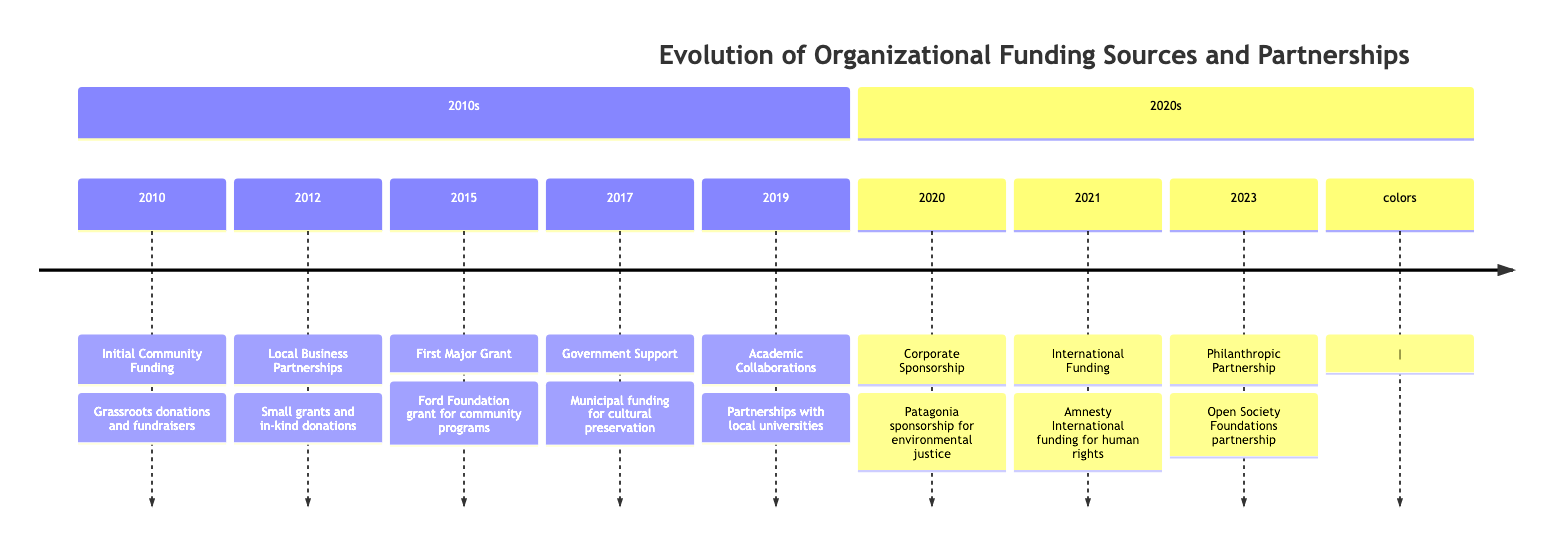What year did the organization receive its first significant grant? The timeline indicates that the organization secured its first major grant from the Ford Foundation in the year 2015.
Answer: 2015 What partnership was established in 2023? According to the diagram, in 2023 the organization established an ongoing partnership with the Open Society Foundations.
Answer: Open Society Foundations How many major grants or funding sources are listed prior to 2020? By counting the relevant events from the years 2010 to 2019, there are five major grants or funding sources listed before 2020: Initial Community Funding, Local Business Partnerships, First Major Grant, Government Support, and Academic Collaborations.
Answer: 5 Which organization provided funding for human rights advocacy in 2021? The timeline specifies that Amnesty International provided funding for human rights advocacy in the year 2021.
Answer: Amnesty International What type of sponsorship did the organization secure in 2020? The diagram shows that in 2020, the organization secured a corporate sponsorship from Patagonia for environmental justice projects.
Answer: Corporate Sponsorship What event occurred in 2017? In the year 2017, the organization received municipal funding to support cultural preservation initiatives.
Answer: Government Support Identify the year when the organization first collaborated with local universities. The timeline indicates that partnerships with local universities began in the year 2019.
Answer: 2019 How did the organization initially fund its activities in 2010? The diagram states that initial community funding in 2010 came from grassroots donations and fundraisers from community members.
Answer: Grassroots donations What is the significance of the event in 2023 regarding structural decolonization? The event established in 2023 signifies an ongoing partnership with the Open Society Foundations for structural decolonization efforts.
Answer: Ongoing partnership for structural decolonization 